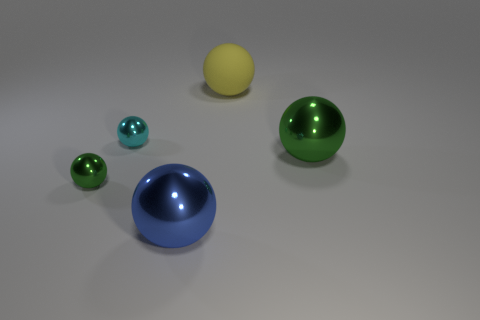Subtract all tiny green metal balls. How many balls are left? 4 Subtract all cyan balls. How many balls are left? 4 Add 3 cyan metal objects. How many objects exist? 8 Subtract 3 balls. How many balls are left? 2 Add 2 tiny metallic spheres. How many tiny metallic spheres exist? 4 Subtract 0 gray spheres. How many objects are left? 5 Subtract all cyan spheres. Subtract all cyan cylinders. How many spheres are left? 4 Subtract all yellow cylinders. How many brown spheres are left? 0 Subtract all green spheres. Subtract all yellow blocks. How many objects are left? 3 Add 1 big yellow objects. How many big yellow objects are left? 2 